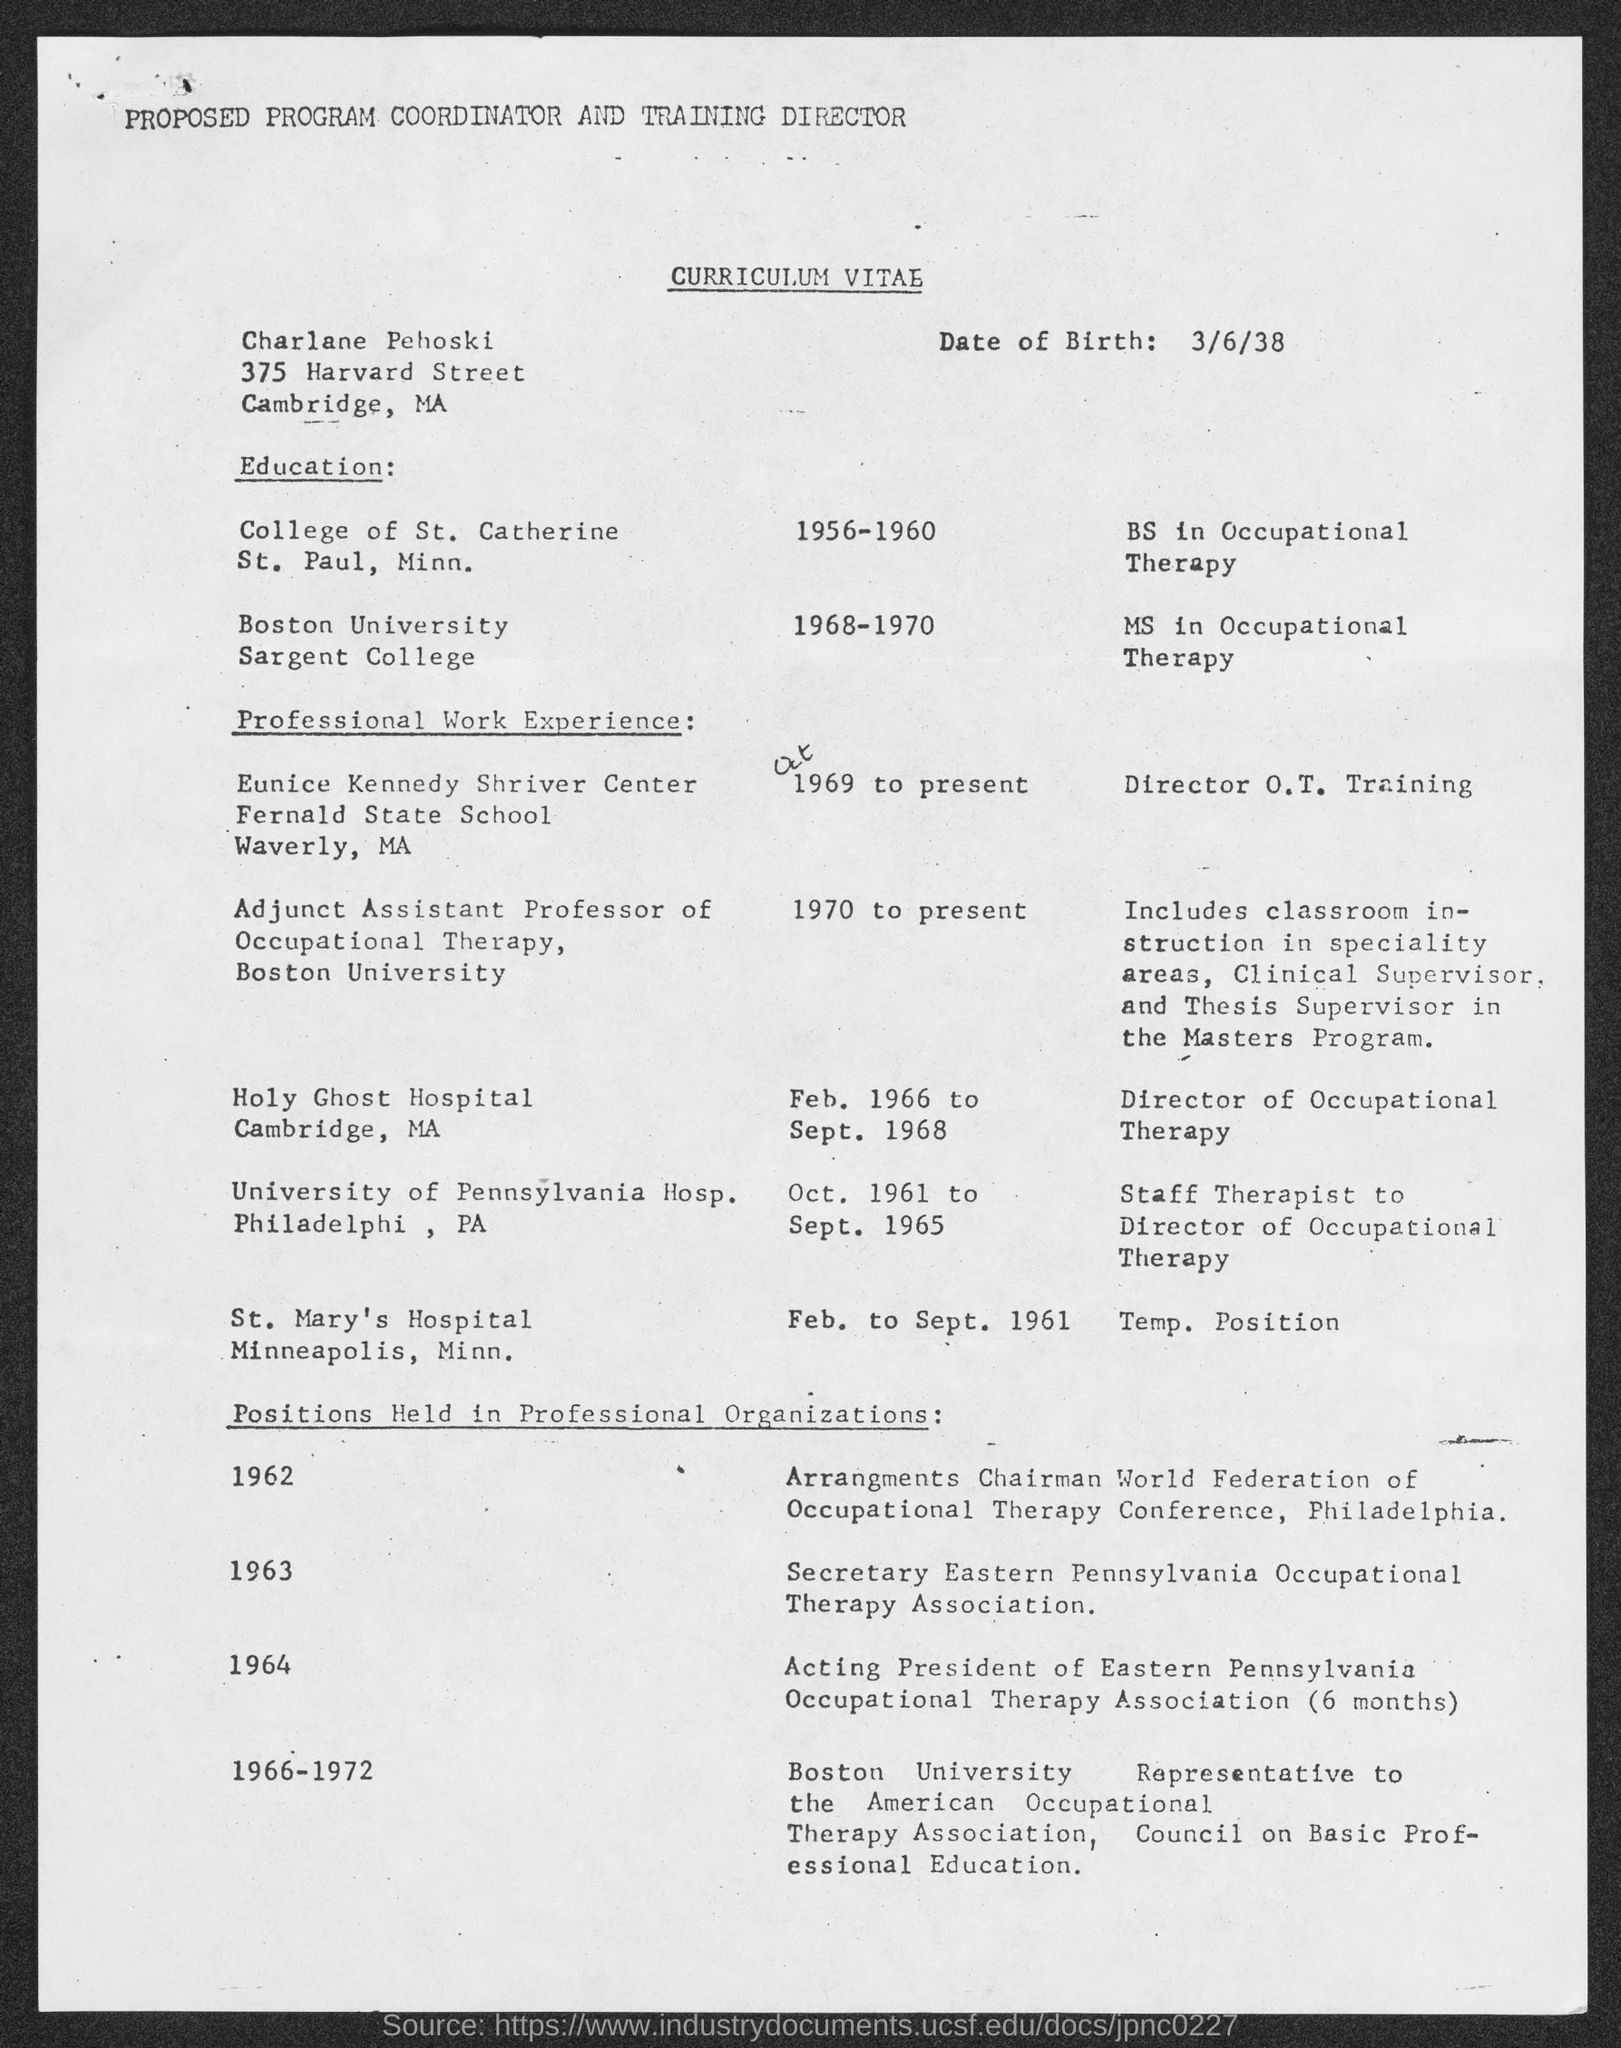Give some essential details in this illustration. The title of the document is "Curriculum Vitae. The date of birth is March 6th, 1938. 